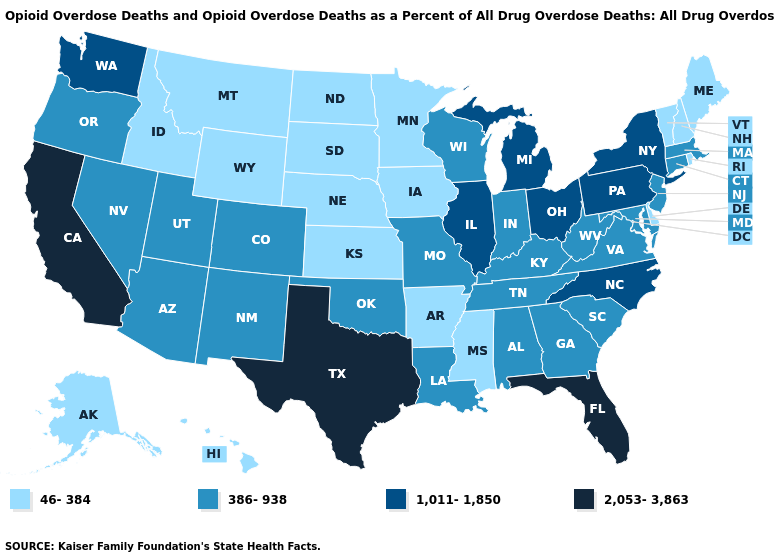Among the states that border California , which have the highest value?
Concise answer only. Arizona, Nevada, Oregon. Among the states that border Vermont , does Massachusetts have the lowest value?
Answer briefly. No. Name the states that have a value in the range 2,053-3,863?
Keep it brief. California, Florida, Texas. What is the value of Nevada?
Quick response, please. 386-938. Name the states that have a value in the range 46-384?
Quick response, please. Alaska, Arkansas, Delaware, Hawaii, Idaho, Iowa, Kansas, Maine, Minnesota, Mississippi, Montana, Nebraska, New Hampshire, North Dakota, Rhode Island, South Dakota, Vermont, Wyoming. Which states have the lowest value in the USA?
Be succinct. Alaska, Arkansas, Delaware, Hawaii, Idaho, Iowa, Kansas, Maine, Minnesota, Mississippi, Montana, Nebraska, New Hampshire, North Dakota, Rhode Island, South Dakota, Vermont, Wyoming. Which states have the lowest value in the USA?
Give a very brief answer. Alaska, Arkansas, Delaware, Hawaii, Idaho, Iowa, Kansas, Maine, Minnesota, Mississippi, Montana, Nebraska, New Hampshire, North Dakota, Rhode Island, South Dakota, Vermont, Wyoming. Does Georgia have a higher value than Missouri?
Keep it brief. No. Among the states that border Iowa , does Missouri have the lowest value?
Answer briefly. No. Is the legend a continuous bar?
Give a very brief answer. No. Which states have the highest value in the USA?
Concise answer only. California, Florida, Texas. Does South Carolina have the lowest value in the USA?
Quick response, please. No. What is the value of Nevada?
Answer briefly. 386-938. Which states have the lowest value in the USA?
Answer briefly. Alaska, Arkansas, Delaware, Hawaii, Idaho, Iowa, Kansas, Maine, Minnesota, Mississippi, Montana, Nebraska, New Hampshire, North Dakota, Rhode Island, South Dakota, Vermont, Wyoming. Name the states that have a value in the range 2,053-3,863?
Keep it brief. California, Florida, Texas. 